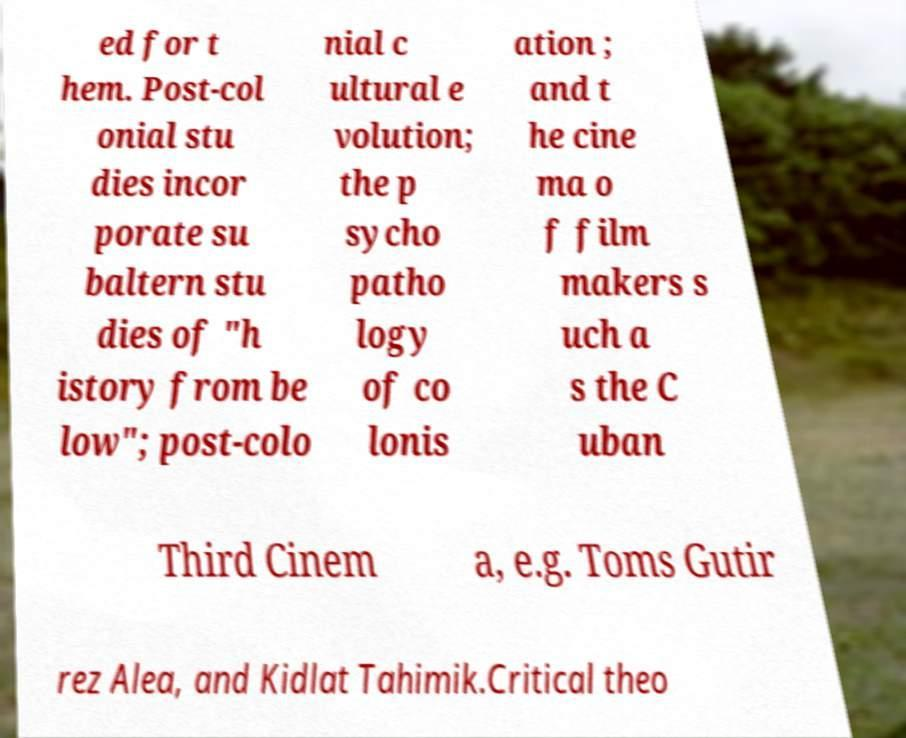What messages or text are displayed in this image? I need them in a readable, typed format. ed for t hem. Post-col onial stu dies incor porate su baltern stu dies of "h istory from be low"; post-colo nial c ultural e volution; the p sycho patho logy of co lonis ation ; and t he cine ma o f film makers s uch a s the C uban Third Cinem a, e.g. Toms Gutir rez Alea, and Kidlat Tahimik.Critical theo 